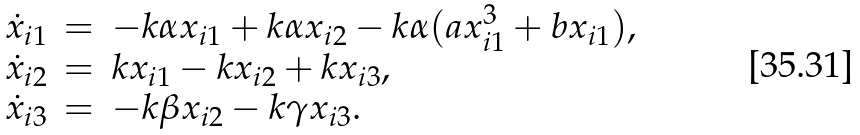Convert formula to latex. <formula><loc_0><loc_0><loc_500><loc_500>\begin{array} { c c l } \dot { x } _ { i 1 } & = & - k \alpha x _ { i 1 } + k \alpha x _ { i 2 } - k \alpha ( a x _ { i 1 } ^ { 3 } + b x _ { i 1 } ) , \\ \dot { x } _ { i 2 } & = & k x _ { i 1 } - k x _ { i 2 } + k x _ { i 3 } , \\ \dot { x } _ { i 3 } & = & - k \beta x _ { i 2 } - k \gamma x _ { i 3 } . \end{array}</formula> 